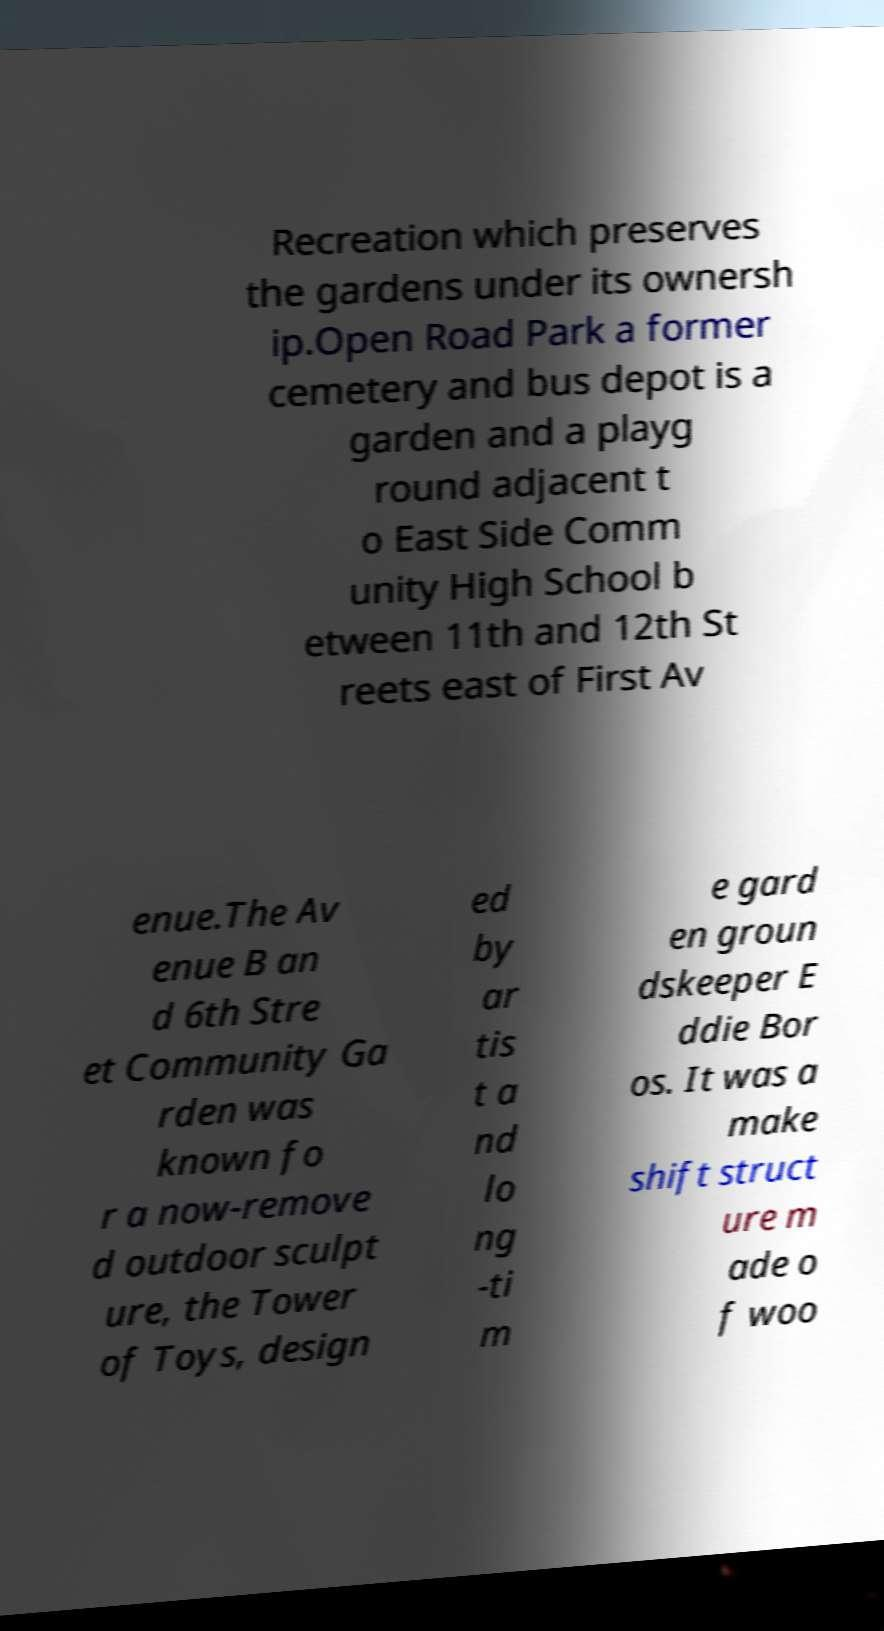Could you extract and type out the text from this image? Recreation which preserves the gardens under its ownersh ip.Open Road Park a former cemetery and bus depot is a garden and a playg round adjacent t o East Side Comm unity High School b etween 11th and 12th St reets east of First Av enue.The Av enue B an d 6th Stre et Community Ga rden was known fo r a now-remove d outdoor sculpt ure, the Tower of Toys, design ed by ar tis t a nd lo ng -ti m e gard en groun dskeeper E ddie Bor os. It was a make shift struct ure m ade o f woo 